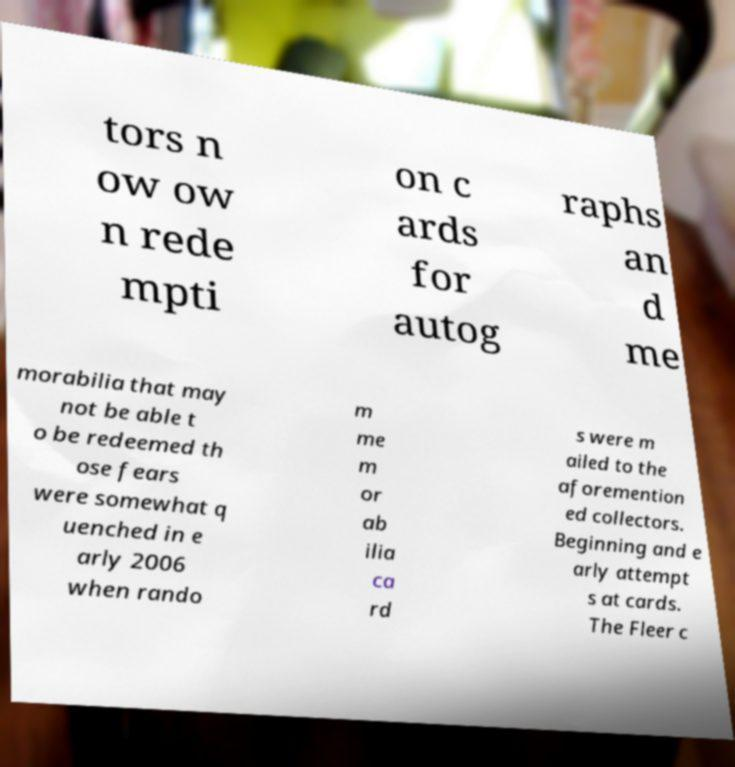Please read and relay the text visible in this image. What does it say? tors n ow ow n rede mpti on c ards for autog raphs an d me morabilia that may not be able t o be redeemed th ose fears were somewhat q uenched in e arly 2006 when rando m me m or ab ilia ca rd s were m ailed to the aforemention ed collectors. Beginning and e arly attempt s at cards. The Fleer c 